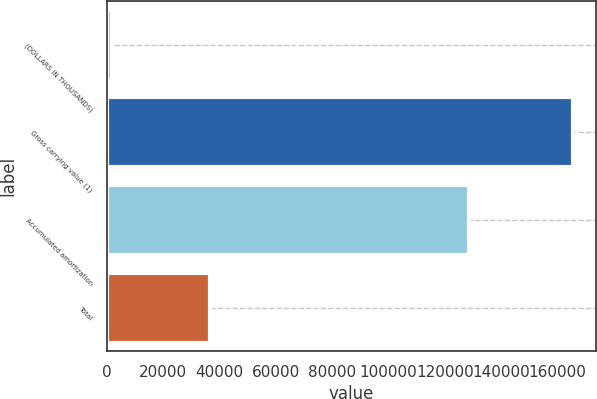Convert chart. <chart><loc_0><loc_0><loc_500><loc_500><bar_chart><fcel>(DOLLARS IN THOUSANDS)<fcel>Gross carrying value (1)<fcel>Accumulated amortization<fcel>Total<nl><fcel>2012<fcel>165406<fcel>128718<fcel>36688<nl></chart> 